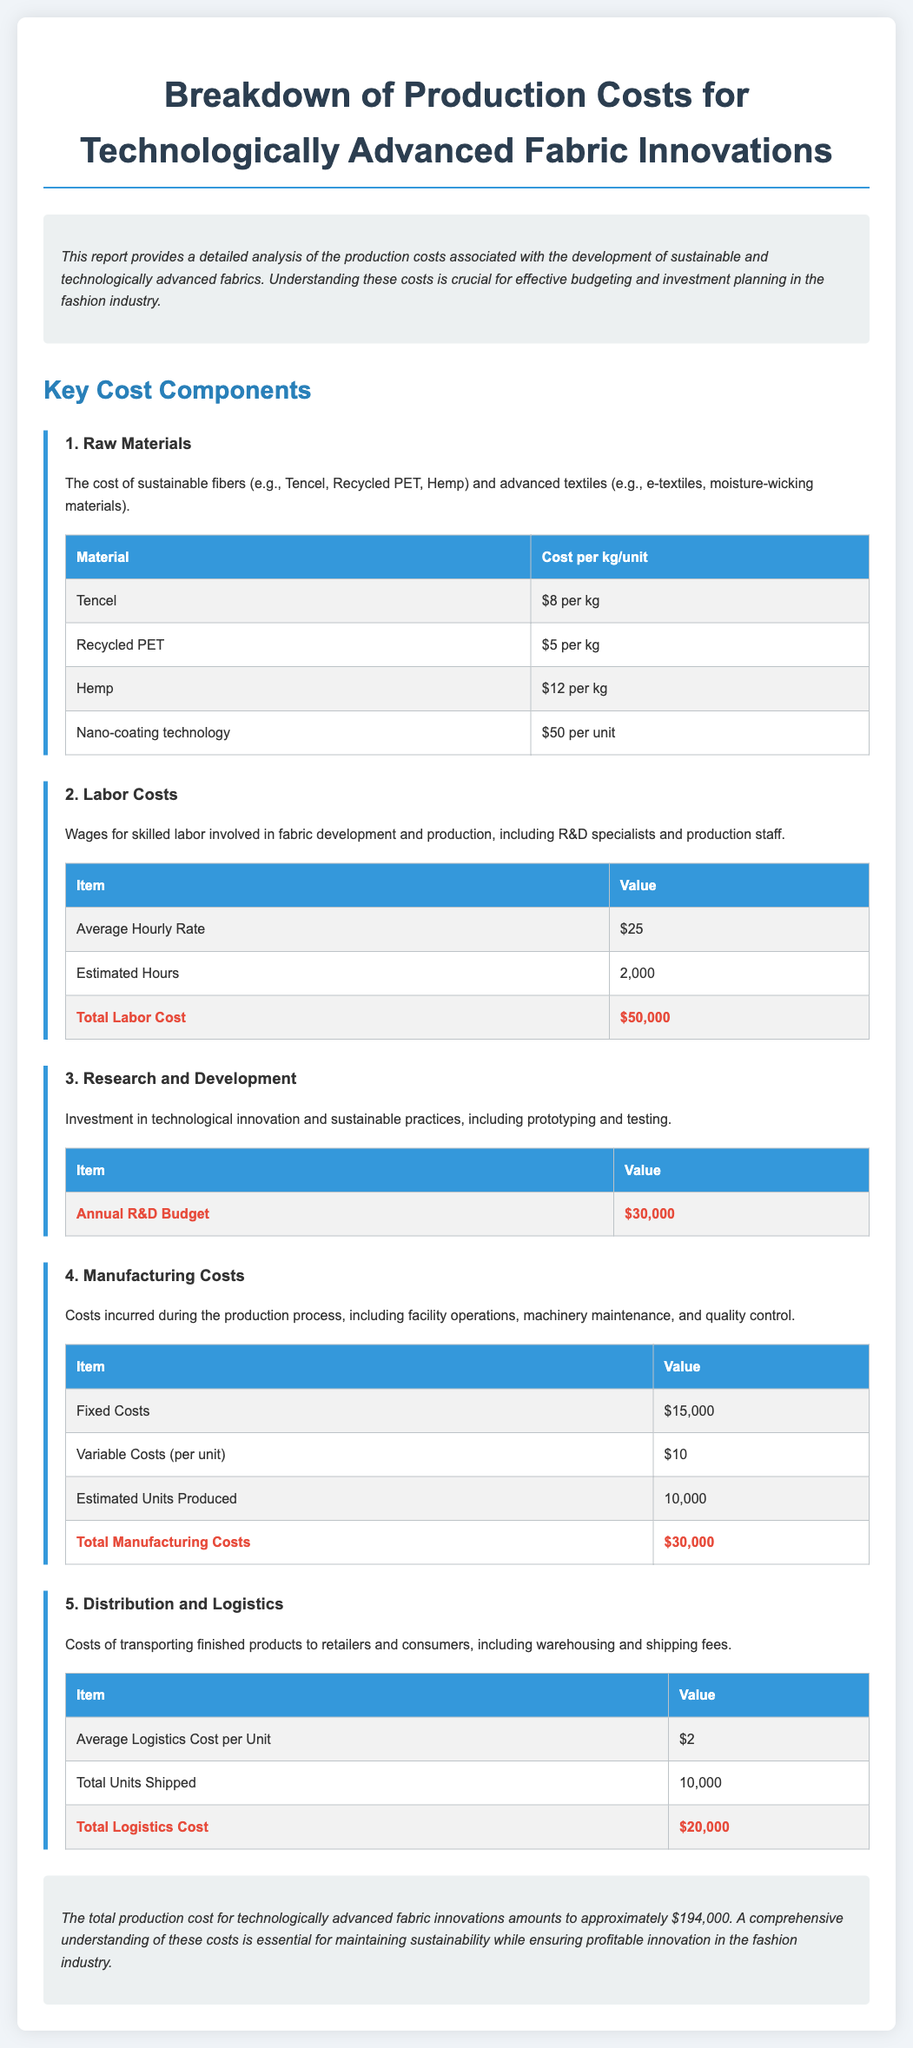what is the cost of Tencel per kg? The cost of Tencel is listed in the raw materials section of the document, which states it is $8 per kg.
Answer: $8 per kg what is the total labor cost? The total labor cost can be found in the labor costs section, which summarizes that it is $50,000.
Answer: $50,000 how many estimated hours are involved in labor costs? The estimated hours for labor costs are specified in the labor costs table as 2,000 hours.
Answer: 2,000 what is the annual R&D budget? The annual R&D budget is detailed in the research and development section, which totals $30,000.
Answer: $30,000 what are the total logistics costs? The total logistics costs are indicated in the distribution and logistics section and amount to $20,000.
Answer: $20,000 how many units are estimated to be produced? The estimated units produced is stated in the manufacturing costs section as 10,000 units.
Answer: 10,000 what is the total production cost for technologically advanced fabric innovations? The total production cost is provided in the conclusion of the document, which sums to approximately $194,000.
Answer: $194,000 what is the average logistics cost per unit? The average logistics cost per unit is mentioned in the distribution and logistics section as $2.
Answer: $2 what type of materials are considered raw materials in this report? Raw materials include sustainable fibers like Tencel, Recycled PET, and Hemp, as mentioned in the raw materials section.
Answer: Tencel, Recycled PET, Hemp 